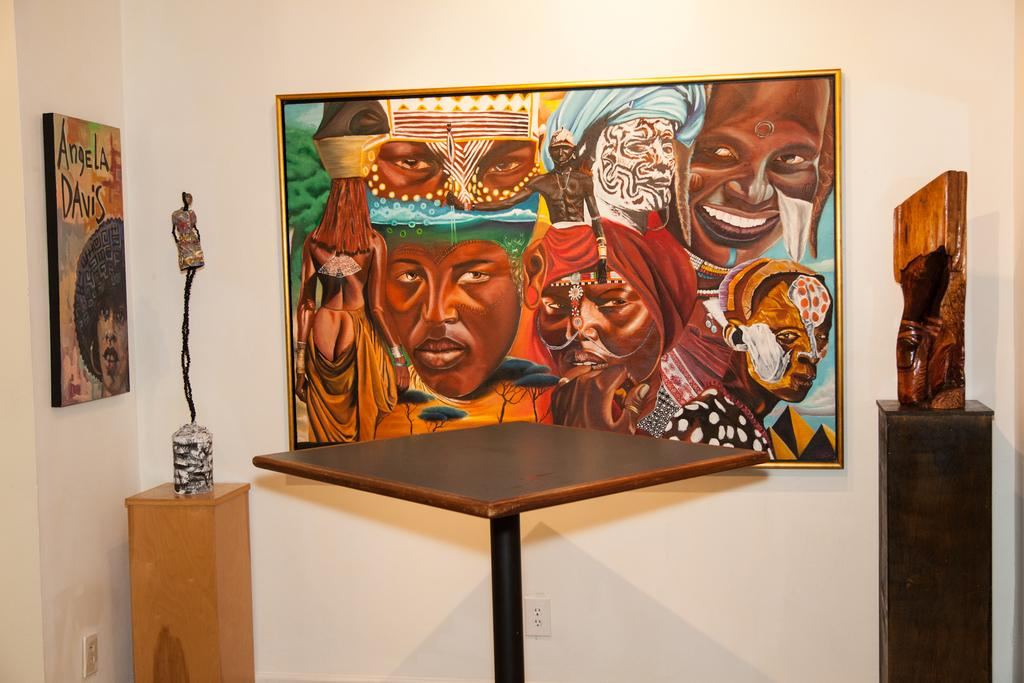What is the main object in the image? There is a table stand in the image. What is placed on the table stand? There are objects on a wooden stand in the image. What can be seen on the walls in the image? Painting boards are present on the walls in the image. How many kites are being flown by the person in the image? There is no person or kite present in the image. What is the limit of the wrist in the image? There is no reference to a wrist or any limitations in the image. 